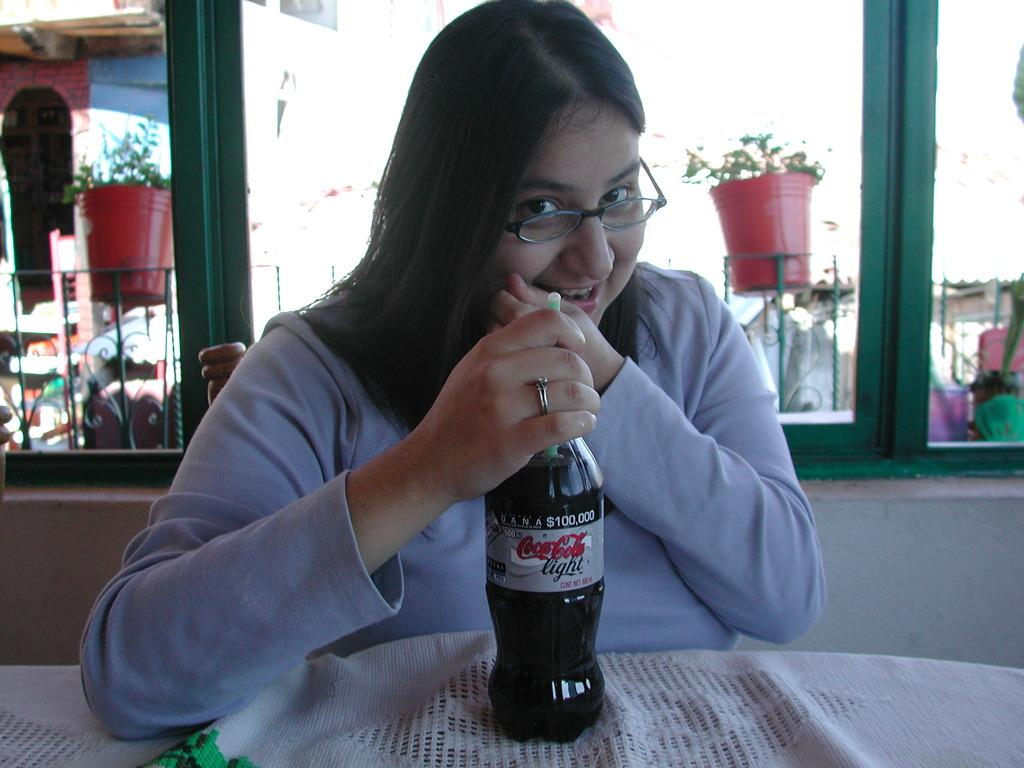What object is present in the image that is typically used for cooking or storage? There is a pot in the image. What is the woman in the image doing? The woman is sitting on a chair in the image. What piece of furniture is present in the image that is used for placing objects? There is a table in the image. What object is on the table in the image? There is a bottle on the table in the image. Can you see the moon in the image? No, the moon is not present in the image. What type of wax is being used by the woman in the image? There is no wax present in the image, nor is the woman using any wax. 